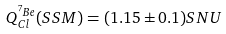<formula> <loc_0><loc_0><loc_500><loc_500>Q ^ { ^ { 7 } B e } _ { C l } ( S S M ) = ( 1 . 1 5 \pm 0 . 1 ) S N U</formula> 